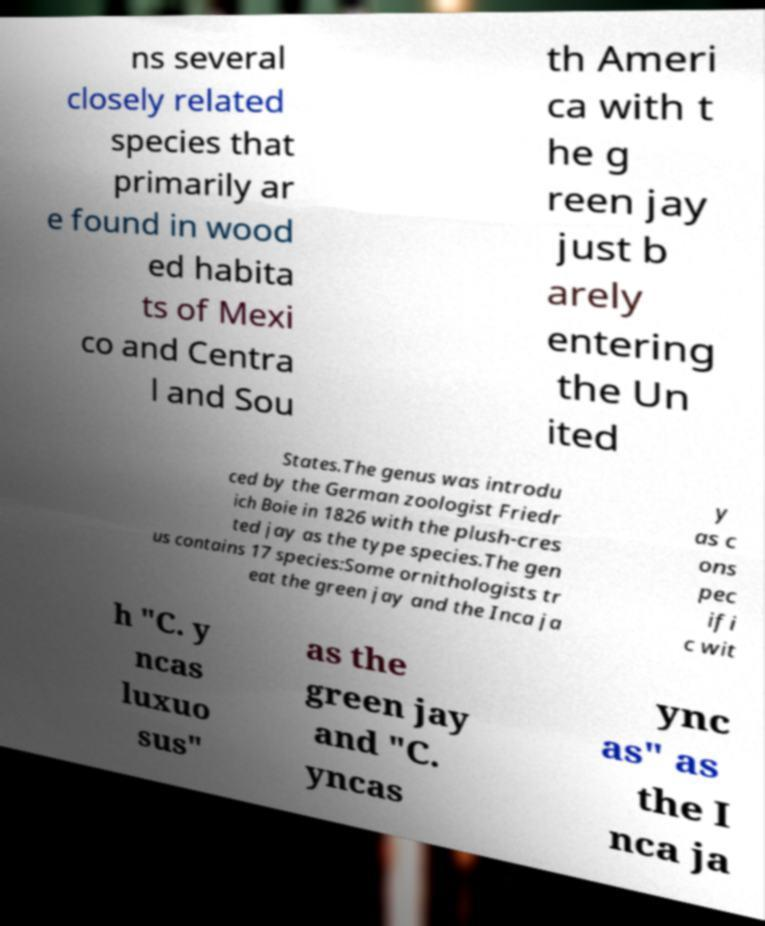Please read and relay the text visible in this image. What does it say? ns several closely related species that primarily ar e found in wood ed habita ts of Mexi co and Centra l and Sou th Ameri ca with t he g reen jay just b arely entering the Un ited States.The genus was introdu ced by the German zoologist Friedr ich Boie in 1826 with the plush-cres ted jay as the type species.The gen us contains 17 species:Some ornithologists tr eat the green jay and the Inca ja y as c ons pec ifi c wit h "C. y ncas luxuo sus" as the green jay and "C. yncas ync as" as the I nca ja 